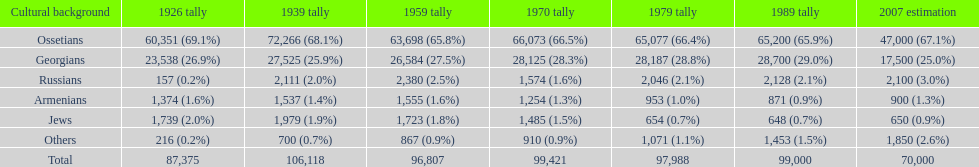Which population had the most people in 1926? Ossetians. 